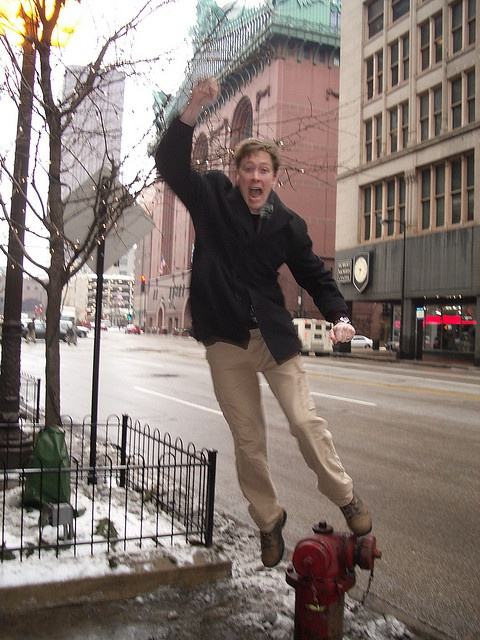Describe the objects in this image and their specific colors. I can see people in ivory, black, gray, and maroon tones, fire hydrant in ivory, black, maroon, and gray tones, truck in ivory, tan, darkgray, and beige tones, clock in ivory, beige, gray, and darkgray tones, and car in ivory, gray, darkgray, lightgray, and black tones in this image. 